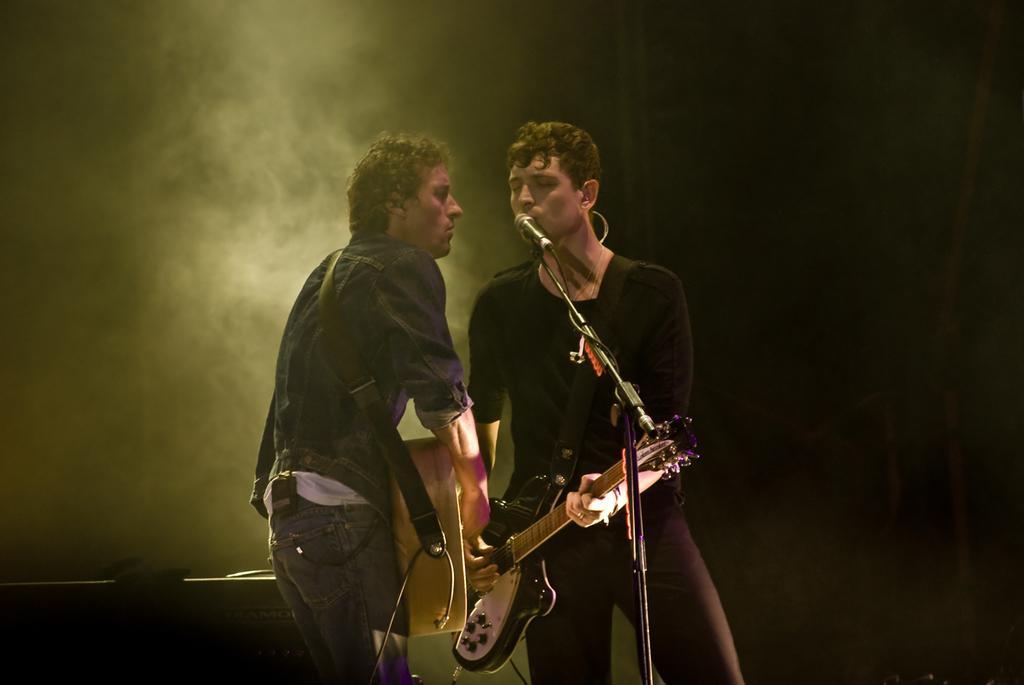Could you give a brief overview of what you see in this image? Two persons are singing in the microphone and playing the guitars. 